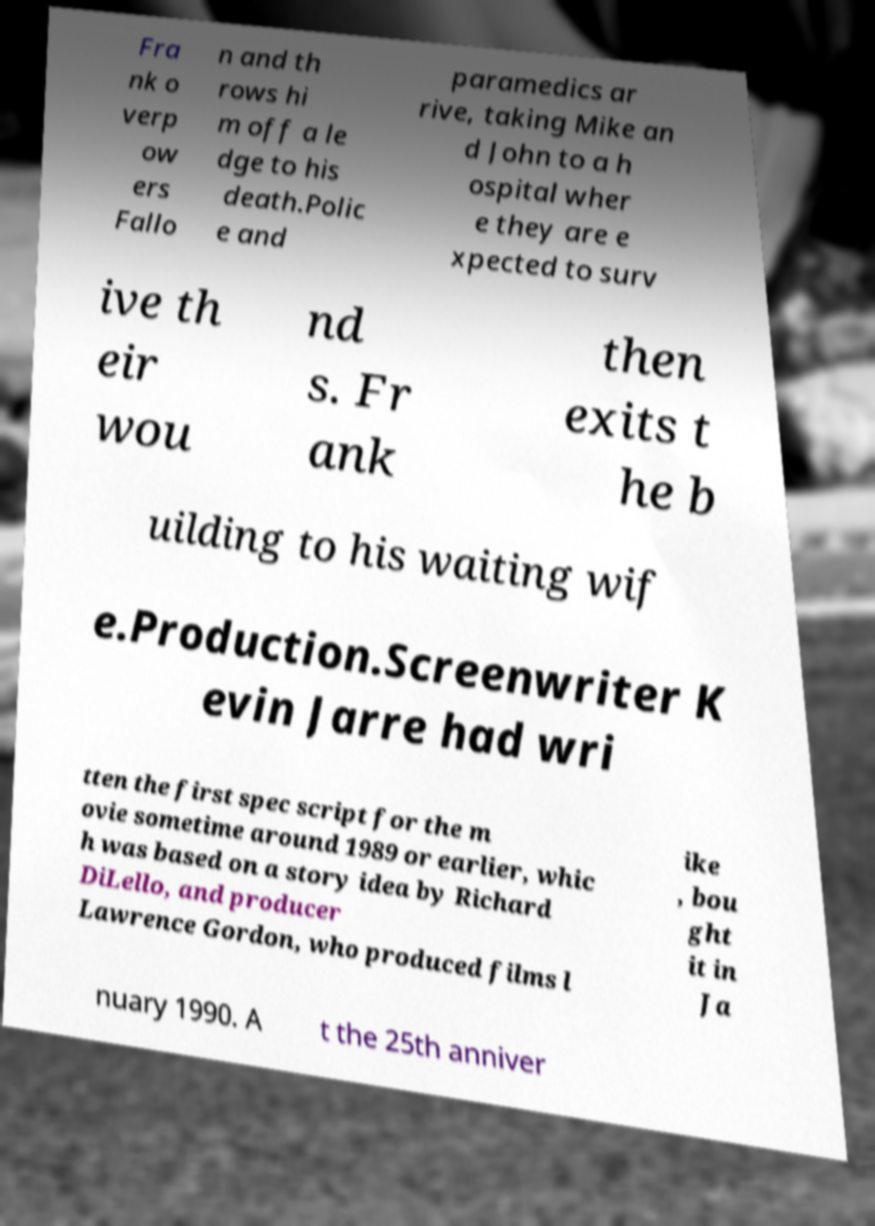Please identify and transcribe the text found in this image. Fra nk o verp ow ers Fallo n and th rows hi m off a le dge to his death.Polic e and paramedics ar rive, taking Mike an d John to a h ospital wher e they are e xpected to surv ive th eir wou nd s. Fr ank then exits t he b uilding to his waiting wif e.Production.Screenwriter K evin Jarre had wri tten the first spec script for the m ovie sometime around 1989 or earlier, whic h was based on a story idea by Richard DiLello, and producer Lawrence Gordon, who produced films l ike , bou ght it in Ja nuary 1990. A t the 25th anniver 